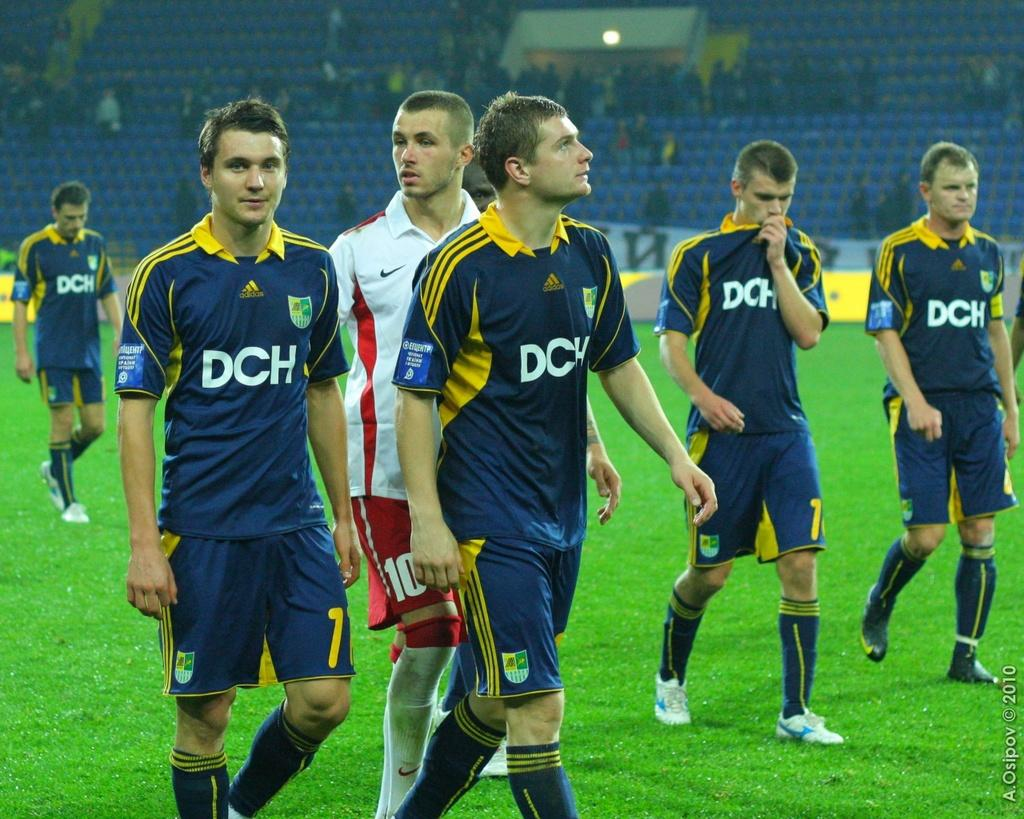<image>
Present a compact description of the photo's key features. Soccer players have the team name DCH on their jerseys. 